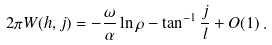Convert formula to latex. <formula><loc_0><loc_0><loc_500><loc_500>2 \pi W ( h , j ) = - \frac { \omega } { \alpha } \ln \rho - \tan ^ { - 1 } \frac { j } { l } + O ( 1 ) \, .</formula> 